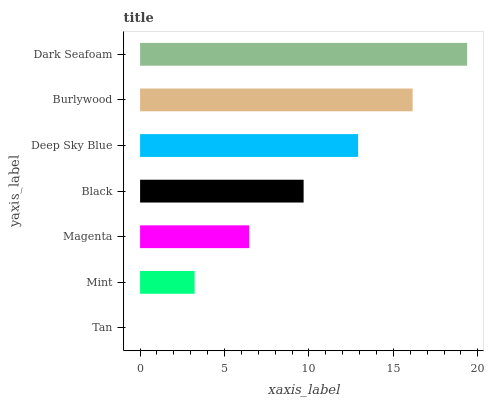Is Tan the minimum?
Answer yes or no. Yes. Is Dark Seafoam the maximum?
Answer yes or no. Yes. Is Mint the minimum?
Answer yes or no. No. Is Mint the maximum?
Answer yes or no. No. Is Mint greater than Tan?
Answer yes or no. Yes. Is Tan less than Mint?
Answer yes or no. Yes. Is Tan greater than Mint?
Answer yes or no. No. Is Mint less than Tan?
Answer yes or no. No. Is Black the high median?
Answer yes or no. Yes. Is Black the low median?
Answer yes or no. Yes. Is Dark Seafoam the high median?
Answer yes or no. No. Is Burlywood the low median?
Answer yes or no. No. 